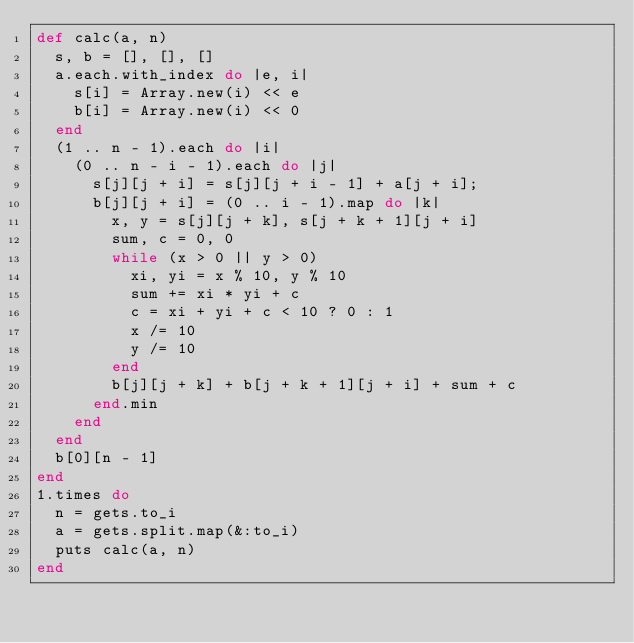Convert code to text. <code><loc_0><loc_0><loc_500><loc_500><_Ruby_>def calc(a, n)
  s, b = [], [], []
  a.each.with_index do |e, i|
    s[i] = Array.new(i) << e
    b[i] = Array.new(i) << 0
  end
  (1 .. n - 1).each do |i|
    (0 .. n - i - 1).each do |j|
      s[j][j + i] = s[j][j + i - 1] + a[j + i];
      b[j][j + i] = (0 .. i - 1).map do |k|
        x, y = s[j][j + k], s[j + k + 1][j + i]
        sum, c = 0, 0
        while (x > 0 || y > 0)
          xi, yi = x % 10, y % 10
          sum += xi * yi + c
          c = xi + yi + c < 10 ? 0 : 1
          x /= 10
          y /= 10
        end
        b[j][j + k] + b[j + k + 1][j + i] + sum + c
      end.min
    end
  end
  b[0][n - 1]
end
1.times do
  n = gets.to_i
  a = gets.split.map(&:to_i)
  puts calc(a, n)
end</code> 